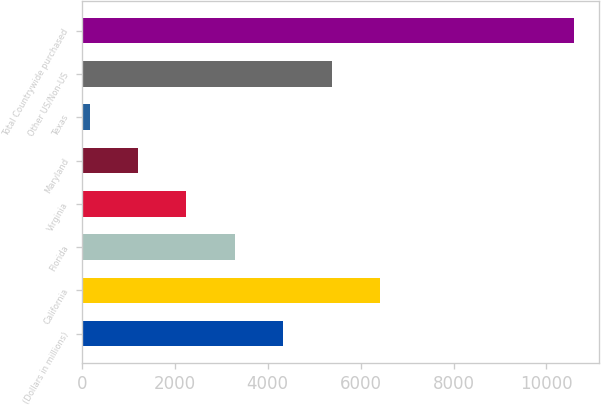Convert chart. <chart><loc_0><loc_0><loc_500><loc_500><bar_chart><fcel>(Dollars in millions)<fcel>California<fcel>Florida<fcel>Virginia<fcel>Maryland<fcel>Texas<fcel>Other US/Non-US<fcel>Total Countrywide purchased<nl><fcel>4335.2<fcel>6420.8<fcel>3292.4<fcel>2249.6<fcel>1206.8<fcel>164<fcel>5378<fcel>10592<nl></chart> 